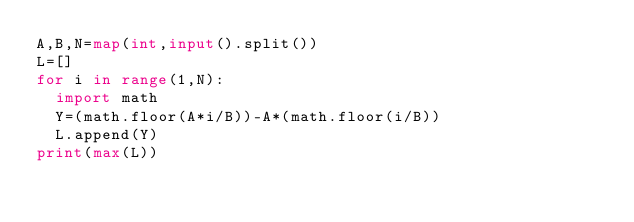Convert code to text. <code><loc_0><loc_0><loc_500><loc_500><_Python_>A,B,N=map(int,input().split())
L=[]
for i in range(1,N):
  import math
  Y=(math.floor(A*i/B))-A*(math.floor(i/B))
  L.append(Y)
print(max(L))</code> 